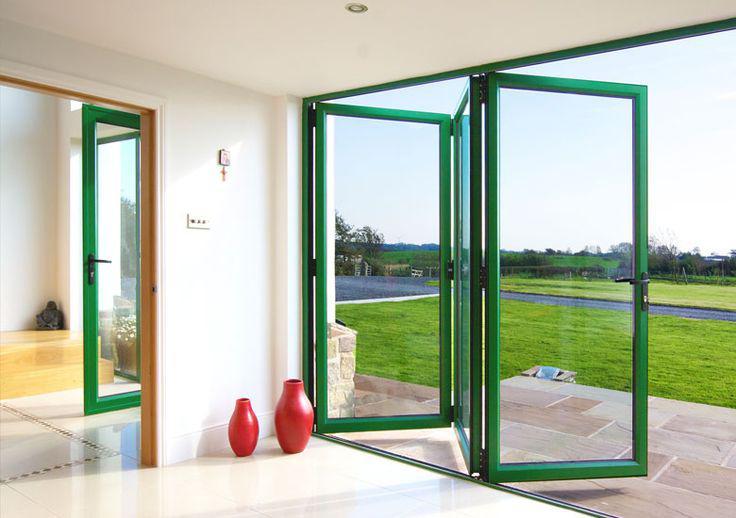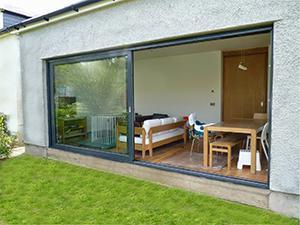The first image is the image on the left, the second image is the image on the right. For the images displayed, is the sentence "The right image is an exterior view of a white dark-framed sliding door unit, opened to show a furnished home interior." factually correct? Answer yes or no. Yes. The first image is the image on the left, the second image is the image on the right. Analyze the images presented: Is the assertion "there is a home with sliding glass doors open and looking into a living area from the outside" valid? Answer yes or no. Yes. 